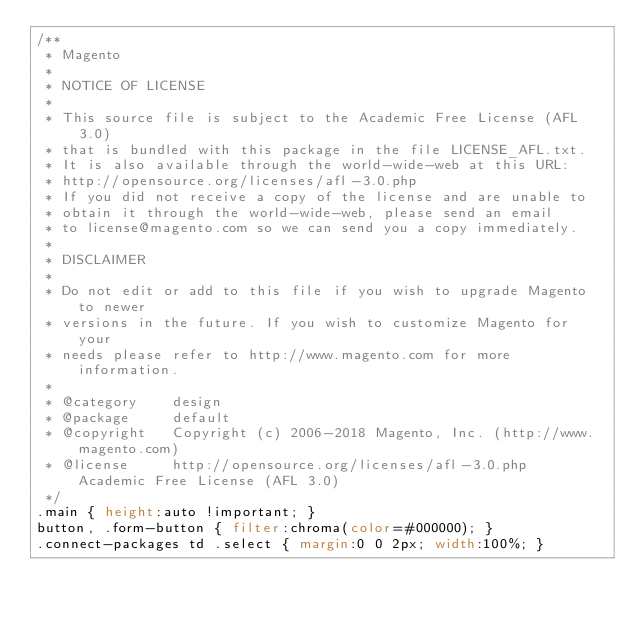Convert code to text. <code><loc_0><loc_0><loc_500><loc_500><_CSS_>/**
 * Magento
 *
 * NOTICE OF LICENSE
 *
 * This source file is subject to the Academic Free License (AFL 3.0)
 * that is bundled with this package in the file LICENSE_AFL.txt.
 * It is also available through the world-wide-web at this URL:
 * http://opensource.org/licenses/afl-3.0.php
 * If you did not receive a copy of the license and are unable to
 * obtain it through the world-wide-web, please send an email
 * to license@magento.com so we can send you a copy immediately.
 *
 * DISCLAIMER
 *
 * Do not edit or add to this file if you wish to upgrade Magento to newer
 * versions in the future. If you wish to customize Magento for your
 * needs please refer to http://www.magento.com for more information.
 *
 * @category    design
 * @package     default
 * @copyright   Copyright (c) 2006-2018 Magento, Inc. (http://www.magento.com)
 * @license     http://opensource.org/licenses/afl-3.0.php  Academic Free License (AFL 3.0)
 */
.main { height:auto !important; }
button, .form-button { filter:chroma(color=#000000); }
.connect-packages td .select { margin:0 0 2px; width:100%; }
</code> 